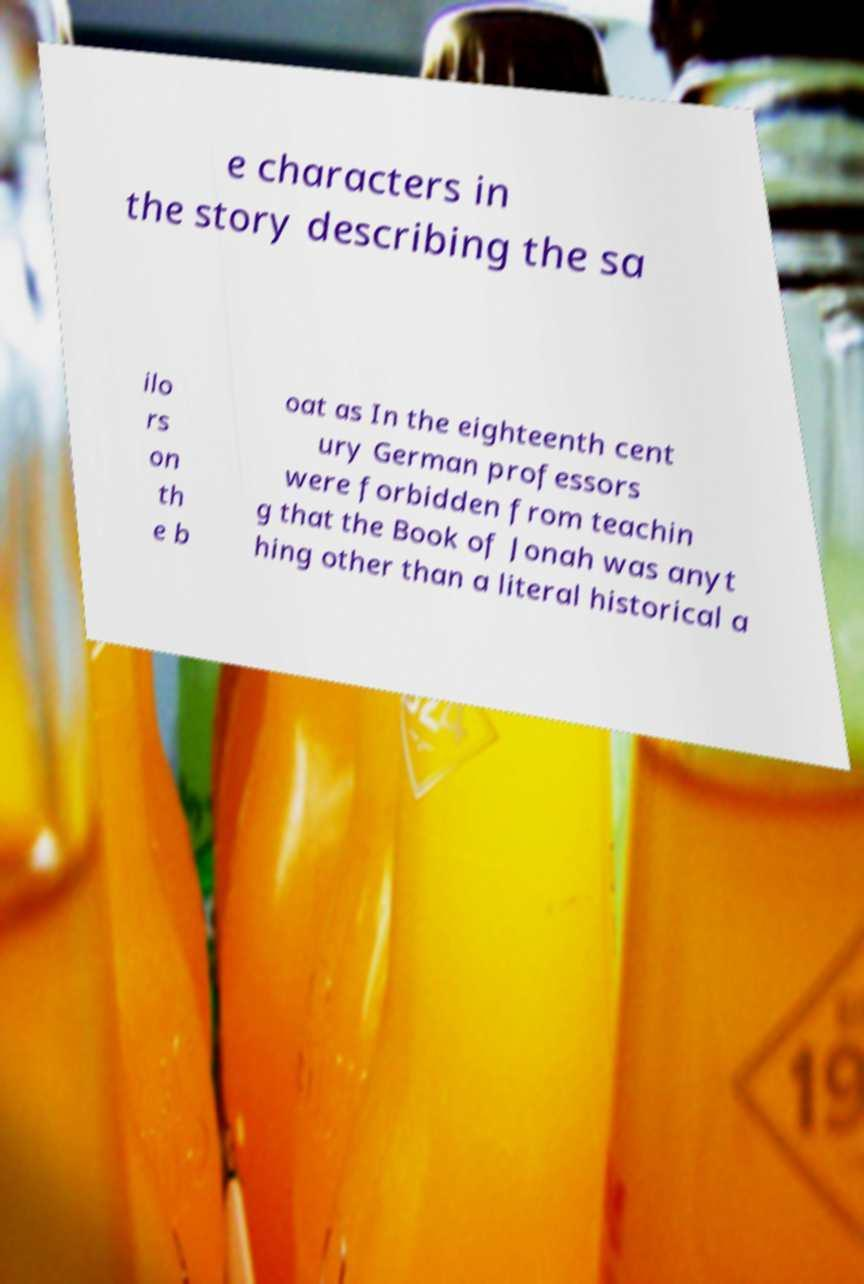For documentation purposes, I need the text within this image transcribed. Could you provide that? e characters in the story describing the sa ilo rs on th e b oat as In the eighteenth cent ury German professors were forbidden from teachin g that the Book of Jonah was anyt hing other than a literal historical a 